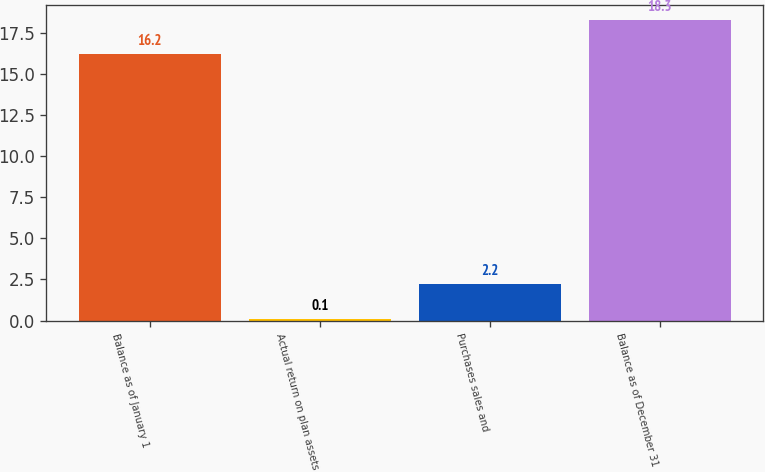<chart> <loc_0><loc_0><loc_500><loc_500><bar_chart><fcel>Balance as of January 1<fcel>Actual return on plan assets<fcel>Purchases sales and<fcel>Balance as of December 31<nl><fcel>16.2<fcel>0.1<fcel>2.2<fcel>18.3<nl></chart> 